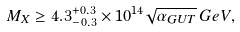<formula> <loc_0><loc_0><loc_500><loc_500>M _ { X } \geq 4 . 3 ^ { + 0 . 3 } _ { - 0 . 3 } \times 1 0 ^ { 1 4 } \sqrt { \alpha _ { G U T } } \, G e V ,</formula> 